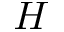Convert formula to latex. <formula><loc_0><loc_0><loc_500><loc_500>H</formula> 